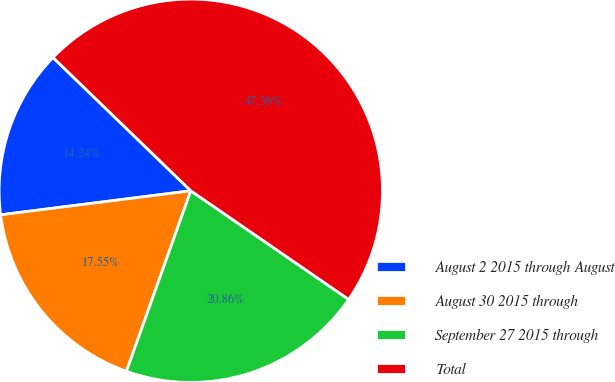<chart> <loc_0><loc_0><loc_500><loc_500><pie_chart><fcel>August 2 2015 through August<fcel>August 30 2015 through<fcel>September 27 2015 through<fcel>Total<nl><fcel>14.24%<fcel>17.55%<fcel>20.86%<fcel>47.36%<nl></chart> 